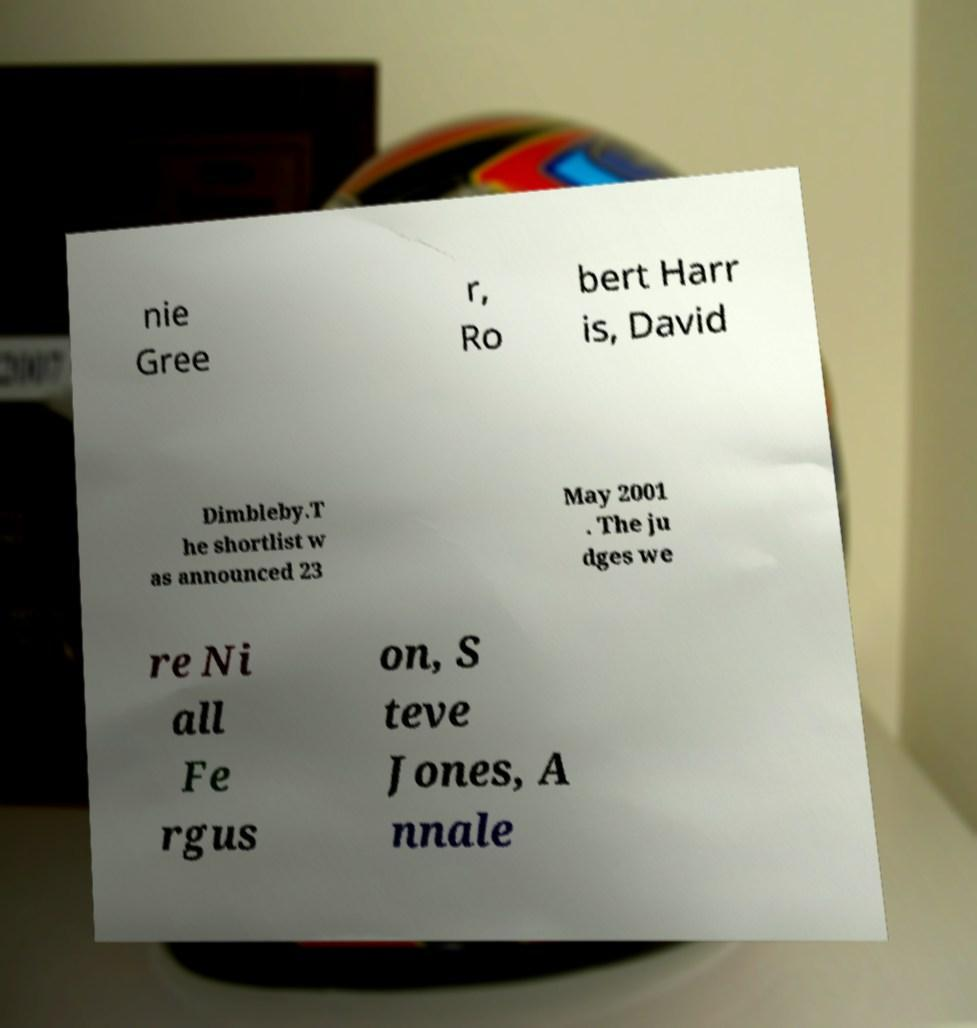There's text embedded in this image that I need extracted. Can you transcribe it verbatim? nie Gree r, Ro bert Harr is, David Dimbleby.T he shortlist w as announced 23 May 2001 . The ju dges we re Ni all Fe rgus on, S teve Jones, A nnale 